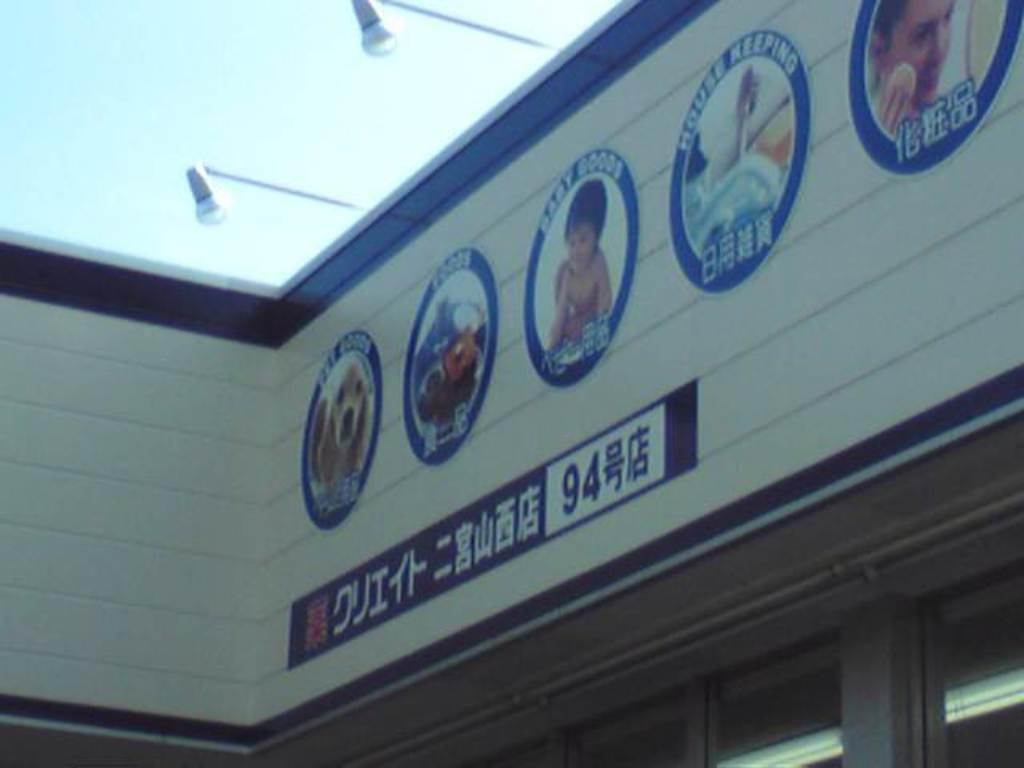What type of location is depicted in the image? The image shows the top of a store. What can be seen on the walls of the store? There are advertising images on the wall. What type of lighting is present in the image? There are lamps visible in the image. What type of pleasure can be seen being experienced by the man in the image? There is no man present in the image, so it is not possible to determine what type of pleasure he might be experiencing. 